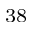<formula> <loc_0><loc_0><loc_500><loc_500>^ { 3 8 }</formula> 